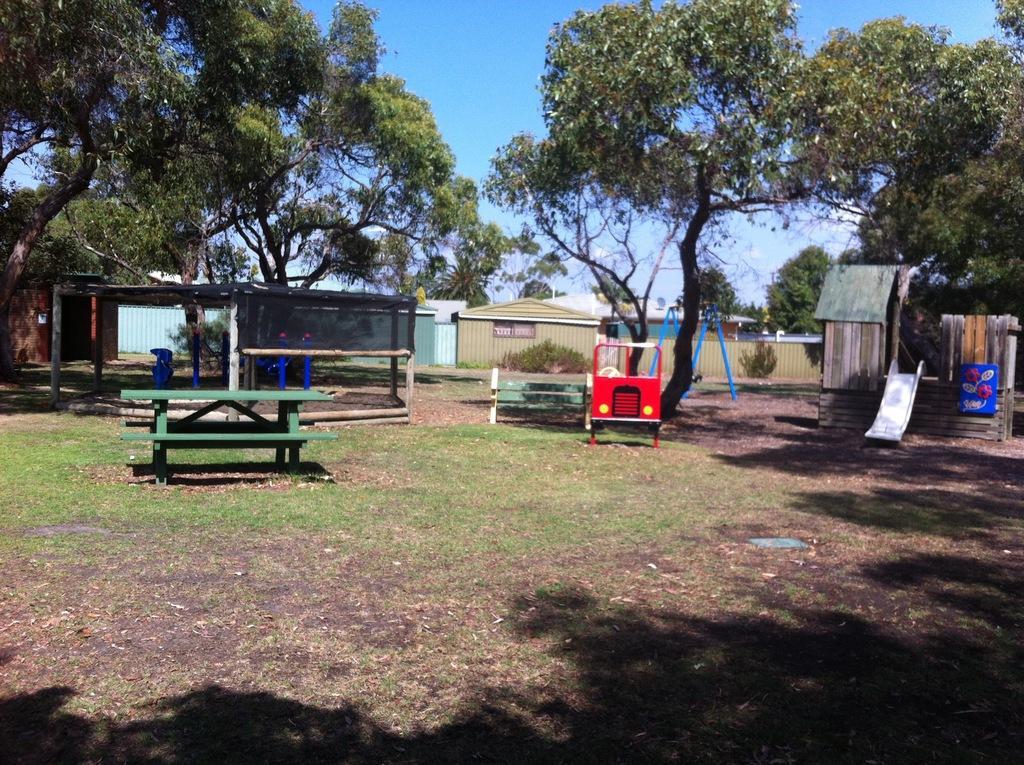Please provide a concise description of this image. In this image there are benches, U shaped swing , plants, buildings, shed, a kids playing car, slider , and in the background there are trees,sky. 